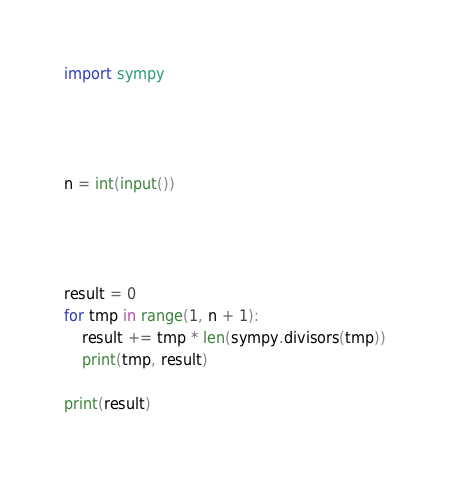<code> <loc_0><loc_0><loc_500><loc_500><_Python_>import sympy




n = int(input())




result = 0
for tmp in range(1, n + 1):
    result += tmp * len(sympy.divisors(tmp))
    print(tmp, result)

print(result)</code> 